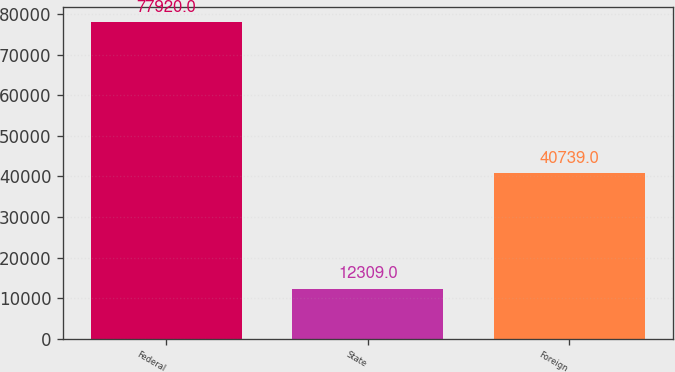Convert chart. <chart><loc_0><loc_0><loc_500><loc_500><bar_chart><fcel>Federal<fcel>State<fcel>Foreign<nl><fcel>77920<fcel>12309<fcel>40739<nl></chart> 